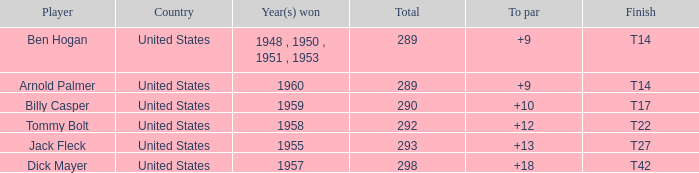Help me parse the entirety of this table. {'header': ['Player', 'Country', 'Year(s) won', 'Total', 'To par', 'Finish'], 'rows': [['Ben Hogan', 'United States', '1948 , 1950 , 1951 , 1953', '289', '+9', 'T14'], ['Arnold Palmer', 'United States', '1960', '289', '+9', 'T14'], ['Billy Casper', 'United States', '1959', '290', '+10', 'T17'], ['Tommy Bolt', 'United States', '1958', '292', '+12', 'T22'], ['Jack Fleck', 'United States', '1955', '293', '+13', 'T27'], ['Dick Mayer', 'United States', '1957', '298', '+18', 'T42']]} What is Player, when Total is 292? Tommy Bolt. 